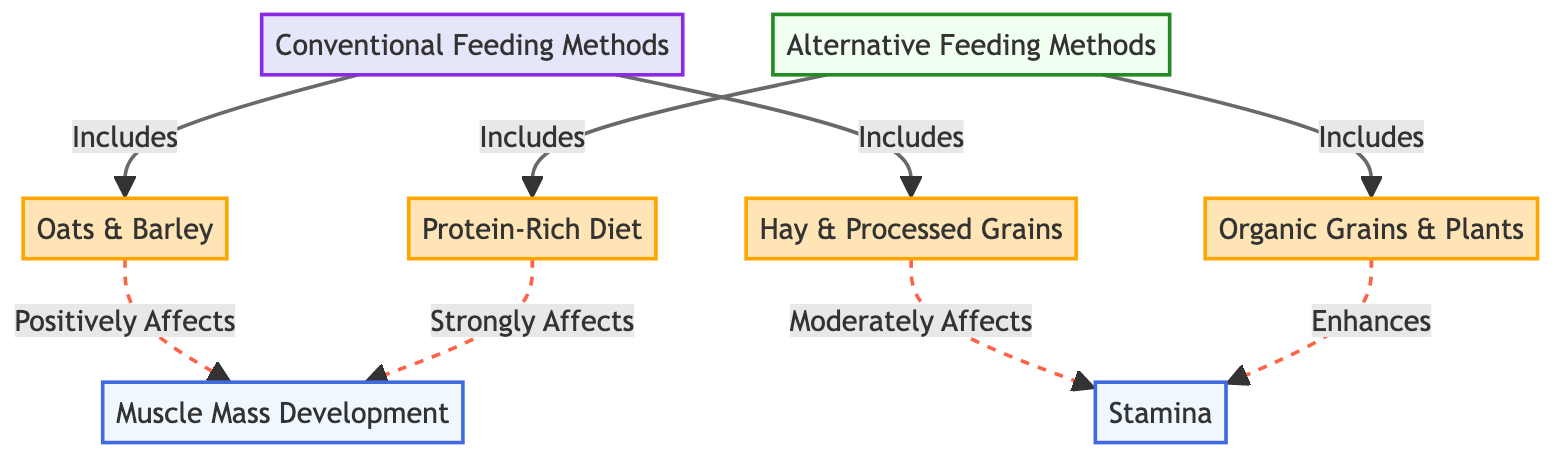What are the two main categories of feeding methods shown in the diagram? The diagram visually distinguishes between two main categories: "Conventional Feeding Methods" and "Alternative Feeding Methods." These categories are represented at the top of the diagram, leading down to specific types of food.
Answer: Conventional Feeding Methods, Alternative Feeding Methods Which food is included under conventional feeding methods? The node labeled "Oats & Barley" is directly connected to the "Conventional Feeding Methods" node in the diagram, indicating it as one of the foods under this category.
Answer: Oats & Barley How does "Protein-Rich Diet" affect muscle mass development? The diagram shows a direct linkage from "Protein-Rich Diet" to "Muscle Mass Development," indicating a strong effect. The label on the arrow specifies that it "Strongly Affects" this aspect, which emphasizes its significant influence on muscle development.
Answer: Strongly Affects What effect do "Organic Grains & Plants" have on stamina? The line connecting "Organic Grains & Plants" to "Stamina" specifies that this food type "Enhances" stamina, indicating a positive relationship. This is stated clearly in the diagram as part of the arrows’ definitions.
Answer: Enhances How many nodes in total represent food sources in the diagram? There are four food nodes in total: "Oats & Barley," "Hay & Processed Grains," "Protein-Rich Diet," and "Organic Grains & Plants." Counting all the food nodes gives a total of four, as illustrated in the diagram.
Answer: Four Which feeding method shows a moderate effect on stamina? The diagram connects "Hay & Processed Grains" to "Stamina," indicating that it "Moderately Affects" stamina. This specific labeling denotes a moderate level of influence based on the feeding method.
Answer: Moderately Affects Which category do the "Oats & Barley" and "Hay & Processed Grains" fall under? Both "Oats & Barley" and "Hay & Processed Grains" are linked to the "Conventional Feeding Methods." Their connection signifies that they are part of the conventional category in the diagram structure.
Answer: Conventional Feeding Methods What is the relationship between "Organic Grains & Plants" and muscle mass development? The diagram does not have a direct line from "Organic Grains & Plants" to "Muscle Mass Development," indicating that while it enhances stamina, it does not show a specified effect on muscle mass. Thus, the relationship is non-existent in the context of this diagram.
Answer: None 